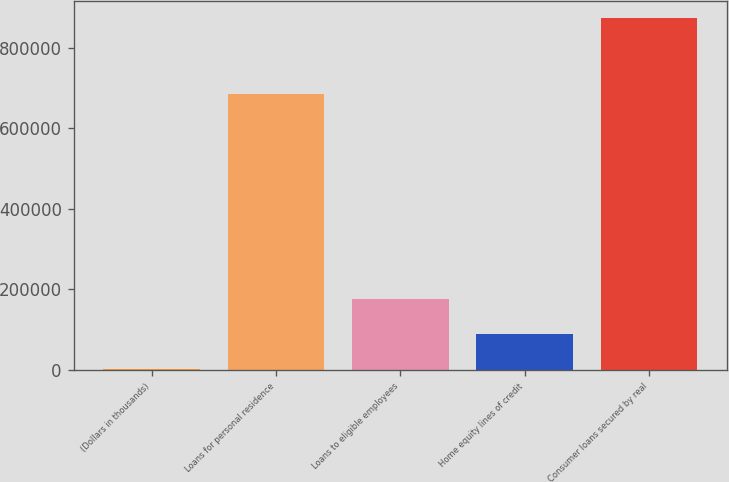<chart> <loc_0><loc_0><loc_500><loc_500><bar_chart><fcel>(Dollars in thousands)<fcel>Loans for personal residence<fcel>Loans to eligible employees<fcel>Home equity lines of credit<fcel>Consumer loans secured by real<nl><fcel>2013<fcel>685327<fcel>176261<fcel>89137.2<fcel>873255<nl></chart> 